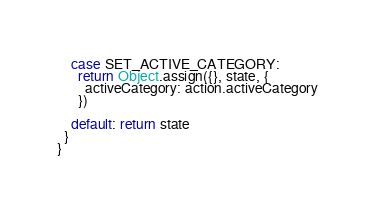Convert code to text. <code><loc_0><loc_0><loc_500><loc_500><_JavaScript_>    case SET_ACTIVE_CATEGORY:
      return Object.assign({}, state, {
        activeCategory: action.activeCategory
      })

    default: return state
  }
}
</code> 